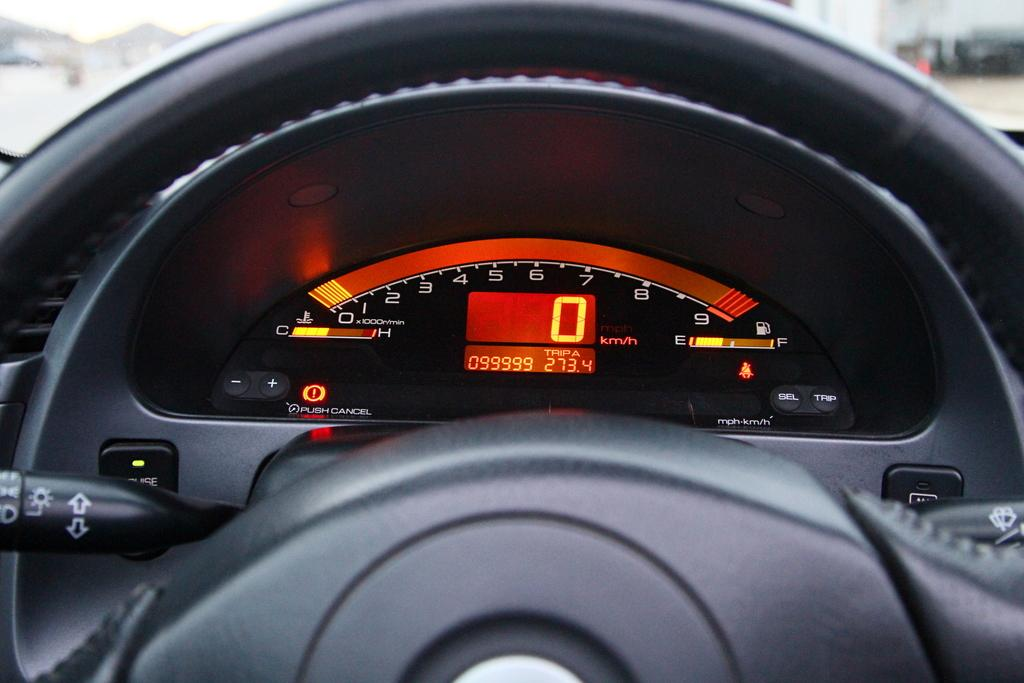What is visible in the image that is related to controlling the vehicle? The steering is visible in the image. What is visible in the image that indicates the speed of the vehicle? The speedometer is visible in the image. How would you describe the background in the image? The background in the image is blurred. What type of advice can be heard coming from the ear in the image? There is no ear present in the image, so it is not possible to determine what, if any, advice might be heard. 